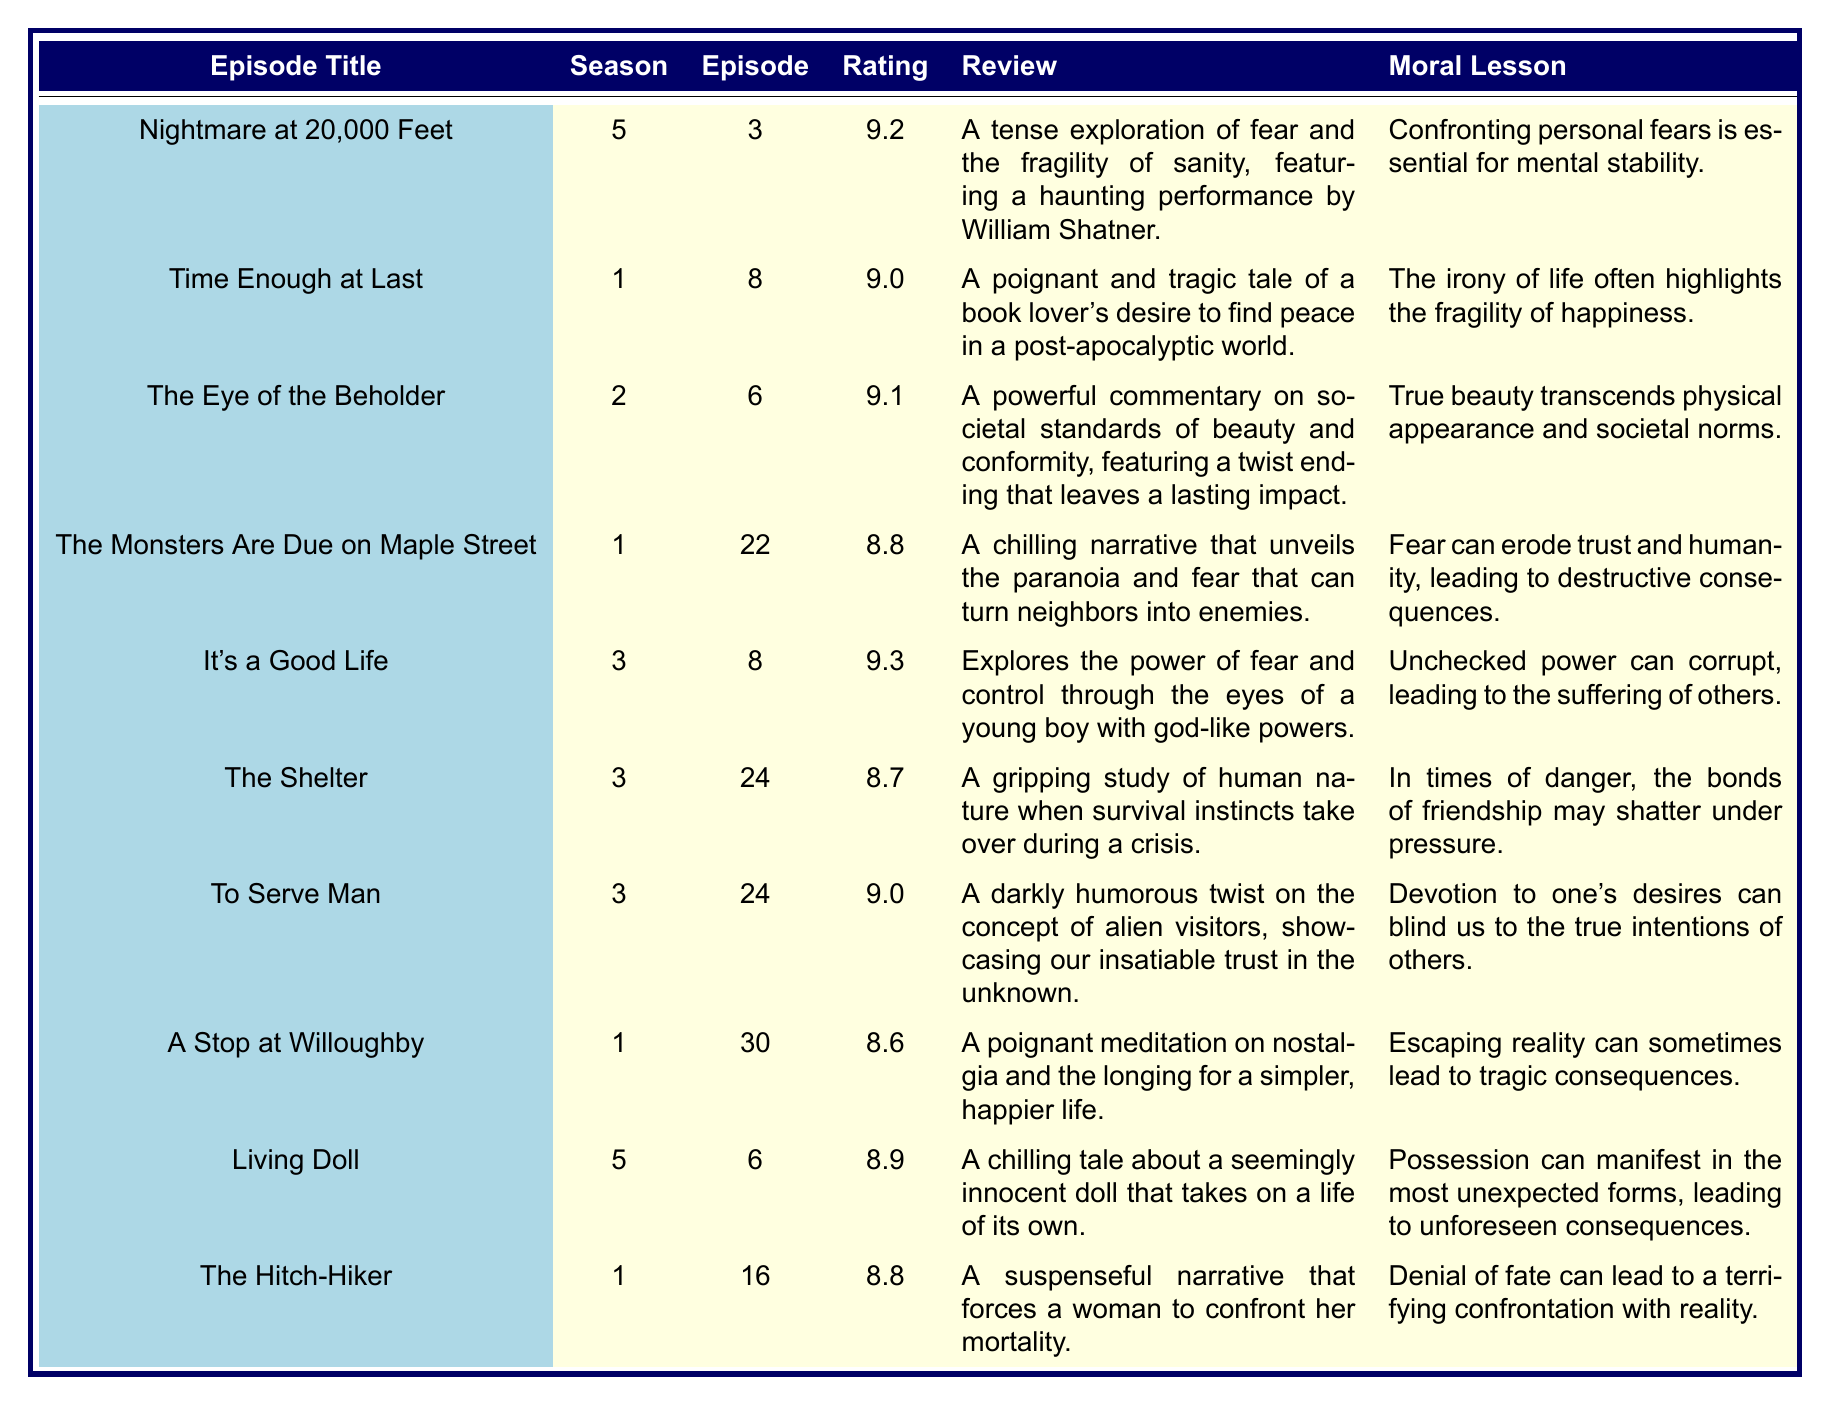What is the episode with the highest rating? The table shows the ratings for each episode. Scanning through the ratings, "It's a Good Life" has the highest rating of 9.3.
Answer: It's a Good Life Which episode features a moral lesson about societal beauty standards? By examining the moral lessons, "The Eye of the Beholder" discusses societal standards of beauty.
Answer: The Eye of the Beholder What is the average rating of all the episodes listed? To find the average, first sum the ratings: (9.2 + 9.0 + 9.1 + 8.8 + 9.3 + 8.7 + 9.0 + 8.6 + 8.9 + 8.8) = 89.4. There are 10 episodes, so the average rating is 89.4 / 10 = 8.94.
Answer: 8.94 How many episodes have a rating of 9.0 or higher? Counting the episodes with a rating of 9.0 or higher: "Nightmare at 20,000 Feet" (9.2), "Time Enough at Last" (9.0), "The Eye of the Beholder" (9.1), "It's a Good Life" (9.3), and "To Serve Man" (9.0) gives us 5 episodes.
Answer: 5 Is there an episode where fear leads to the destruction of trust? The episode "The Monsters Are Due on Maple Street" describes the erosion of trust due to fear.
Answer: Yes What is the difference between the highest and lowest rated episodes? The highest rating is 9.3 ("It's a Good Life") and the lowest is 8.6 ("A Stop at Willoughby"). The difference is 9.3 - 8.6 = 0.7.
Answer: 0.7 Which episode has a review mentioning a haunting performance? The review for "Nightmare at 20,000 Feet" mentions a haunting performance by William Shatner.
Answer: Nightmare at 20,000 Feet Which episodes contain moral lessons about the consequences of power? "It's a Good Life" emphasizes unchecked power leading to others' suffering. There are no other episodes that address this theme.
Answer: It's a Good Life Do any episodes discuss the theme of escaping reality? "A Stop at Willoughby" deals with escaping reality and the tragic consequences that follow.
Answer: Yes What moral lesson is shared by both "Living Doll" and "The Shelter"? "Living Doll" discusses unforeseen consequences of possession, while "The Shelter" highlights the breaking of friendship under pressure. They don't share a moral lesson but both deal with aspects of human nature in crises.
Answer: No shared moral lesson 